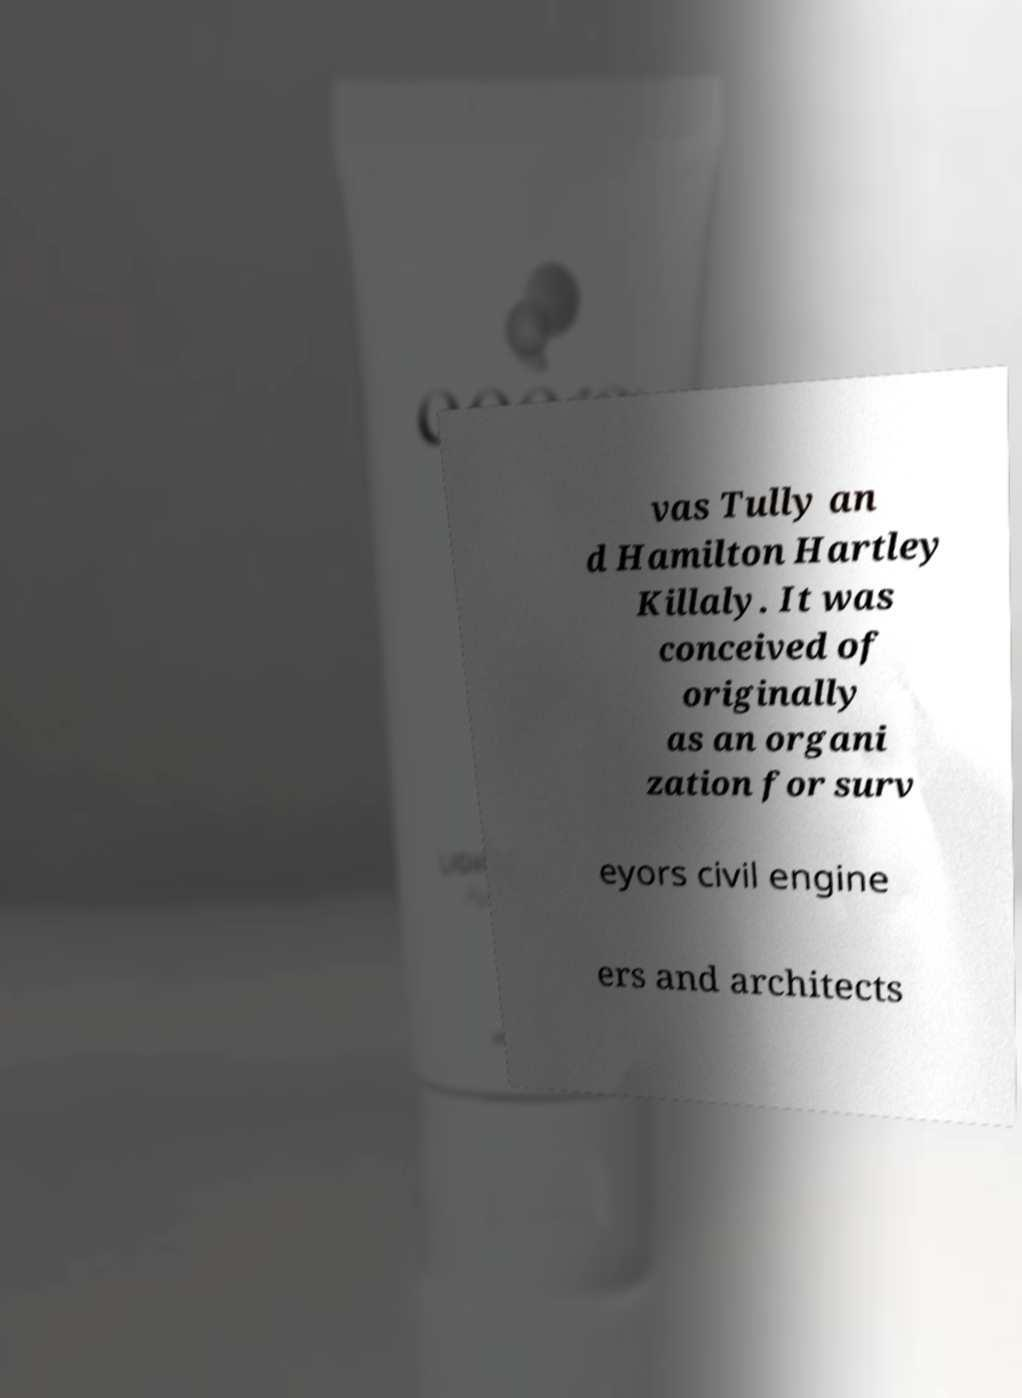Could you assist in decoding the text presented in this image and type it out clearly? vas Tully an d Hamilton Hartley Killaly. It was conceived of originally as an organi zation for surv eyors civil engine ers and architects 